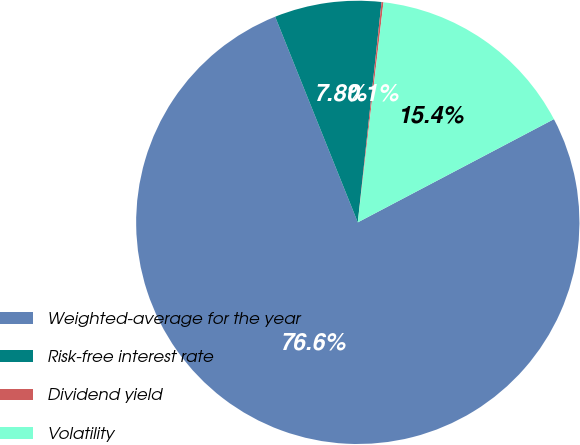Convert chart. <chart><loc_0><loc_0><loc_500><loc_500><pie_chart><fcel>Weighted-average for the year<fcel>Risk-free interest rate<fcel>Dividend yield<fcel>Volatility<nl><fcel>76.63%<fcel>7.79%<fcel>0.14%<fcel>15.44%<nl></chart> 